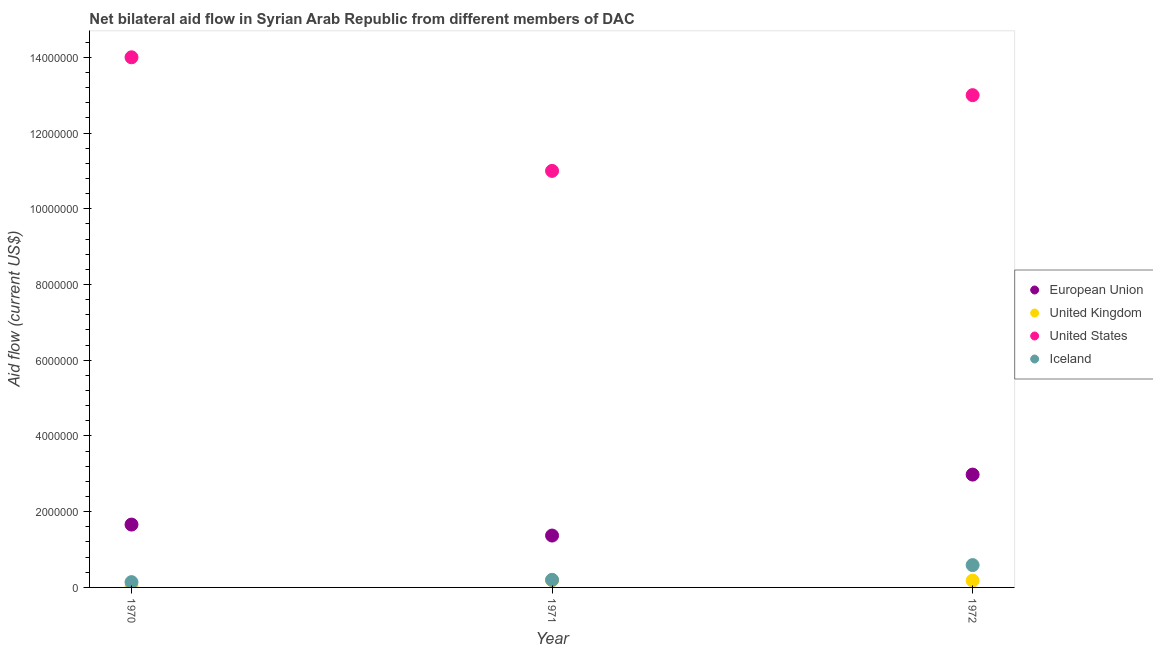How many different coloured dotlines are there?
Your response must be concise. 4. Is the number of dotlines equal to the number of legend labels?
Offer a very short reply. Yes. What is the amount of aid given by eu in 1971?
Ensure brevity in your answer.  1.37e+06. Across all years, what is the maximum amount of aid given by iceland?
Ensure brevity in your answer.  5.90e+05. Across all years, what is the minimum amount of aid given by us?
Provide a succinct answer. 1.10e+07. In which year was the amount of aid given by eu maximum?
Provide a short and direct response. 1972. What is the total amount of aid given by us in the graph?
Offer a terse response. 3.80e+07. What is the difference between the amount of aid given by iceland in 1971 and that in 1972?
Offer a terse response. -3.90e+05. What is the difference between the amount of aid given by uk in 1970 and the amount of aid given by iceland in 1971?
Your answer should be very brief. -1.80e+05. What is the average amount of aid given by eu per year?
Your answer should be very brief. 2.00e+06. In the year 1971, what is the difference between the amount of aid given by uk and amount of aid given by eu?
Keep it short and to the point. -1.18e+06. What is the ratio of the amount of aid given by us in 1971 to that in 1972?
Keep it short and to the point. 0.85. What is the difference between the highest and the lowest amount of aid given by uk?
Offer a very short reply. 1.70e+05. In how many years, is the amount of aid given by iceland greater than the average amount of aid given by iceland taken over all years?
Keep it short and to the point. 1. Is it the case that in every year, the sum of the amount of aid given by iceland and amount of aid given by eu is greater than the sum of amount of aid given by us and amount of aid given by uk?
Offer a terse response. No. Does the amount of aid given by us monotonically increase over the years?
Provide a short and direct response. No. Is the amount of aid given by uk strictly less than the amount of aid given by us over the years?
Your response must be concise. Yes. How many dotlines are there?
Your answer should be compact. 4. How many years are there in the graph?
Ensure brevity in your answer.  3. Does the graph contain any zero values?
Make the answer very short. No. How many legend labels are there?
Ensure brevity in your answer.  4. What is the title of the graph?
Ensure brevity in your answer.  Net bilateral aid flow in Syrian Arab Republic from different members of DAC. Does "Secondary general" appear as one of the legend labels in the graph?
Ensure brevity in your answer.  No. What is the label or title of the X-axis?
Your answer should be compact. Year. What is the label or title of the Y-axis?
Provide a short and direct response. Aid flow (current US$). What is the Aid flow (current US$) in European Union in 1970?
Provide a succinct answer. 1.66e+06. What is the Aid flow (current US$) of United States in 1970?
Provide a succinct answer. 1.40e+07. What is the Aid flow (current US$) of European Union in 1971?
Keep it short and to the point. 1.37e+06. What is the Aid flow (current US$) in United States in 1971?
Offer a terse response. 1.10e+07. What is the Aid flow (current US$) of European Union in 1972?
Offer a terse response. 2.98e+06. What is the Aid flow (current US$) of United States in 1972?
Ensure brevity in your answer.  1.30e+07. What is the Aid flow (current US$) in Iceland in 1972?
Provide a succinct answer. 5.90e+05. Across all years, what is the maximum Aid flow (current US$) of European Union?
Your response must be concise. 2.98e+06. Across all years, what is the maximum Aid flow (current US$) of United Kingdom?
Offer a terse response. 1.90e+05. Across all years, what is the maximum Aid flow (current US$) in United States?
Offer a very short reply. 1.40e+07. Across all years, what is the maximum Aid flow (current US$) in Iceland?
Offer a very short reply. 5.90e+05. Across all years, what is the minimum Aid flow (current US$) in European Union?
Offer a very short reply. 1.37e+06. Across all years, what is the minimum Aid flow (current US$) in United States?
Provide a short and direct response. 1.10e+07. Across all years, what is the minimum Aid flow (current US$) in Iceland?
Ensure brevity in your answer.  1.40e+05. What is the total Aid flow (current US$) in European Union in the graph?
Your response must be concise. 6.01e+06. What is the total Aid flow (current US$) in United Kingdom in the graph?
Make the answer very short. 3.90e+05. What is the total Aid flow (current US$) in United States in the graph?
Offer a very short reply. 3.80e+07. What is the total Aid flow (current US$) in Iceland in the graph?
Provide a succinct answer. 9.30e+05. What is the difference between the Aid flow (current US$) of United Kingdom in 1970 and that in 1971?
Your answer should be very brief. -1.70e+05. What is the difference between the Aid flow (current US$) in United States in 1970 and that in 1971?
Provide a short and direct response. 3.00e+06. What is the difference between the Aid flow (current US$) of Iceland in 1970 and that in 1971?
Make the answer very short. -6.00e+04. What is the difference between the Aid flow (current US$) in European Union in 1970 and that in 1972?
Offer a terse response. -1.32e+06. What is the difference between the Aid flow (current US$) of United States in 1970 and that in 1972?
Keep it short and to the point. 1.00e+06. What is the difference between the Aid flow (current US$) in Iceland in 1970 and that in 1972?
Your response must be concise. -4.50e+05. What is the difference between the Aid flow (current US$) in European Union in 1971 and that in 1972?
Offer a terse response. -1.61e+06. What is the difference between the Aid flow (current US$) of United Kingdom in 1971 and that in 1972?
Offer a very short reply. 10000. What is the difference between the Aid flow (current US$) in Iceland in 1971 and that in 1972?
Give a very brief answer. -3.90e+05. What is the difference between the Aid flow (current US$) of European Union in 1970 and the Aid flow (current US$) of United Kingdom in 1971?
Your response must be concise. 1.47e+06. What is the difference between the Aid flow (current US$) in European Union in 1970 and the Aid flow (current US$) in United States in 1971?
Your answer should be very brief. -9.34e+06. What is the difference between the Aid flow (current US$) of European Union in 1970 and the Aid flow (current US$) of Iceland in 1971?
Make the answer very short. 1.46e+06. What is the difference between the Aid flow (current US$) of United Kingdom in 1970 and the Aid flow (current US$) of United States in 1971?
Keep it short and to the point. -1.10e+07. What is the difference between the Aid flow (current US$) of United States in 1970 and the Aid flow (current US$) of Iceland in 1971?
Your answer should be very brief. 1.38e+07. What is the difference between the Aid flow (current US$) of European Union in 1970 and the Aid flow (current US$) of United Kingdom in 1972?
Give a very brief answer. 1.48e+06. What is the difference between the Aid flow (current US$) of European Union in 1970 and the Aid flow (current US$) of United States in 1972?
Provide a short and direct response. -1.13e+07. What is the difference between the Aid flow (current US$) of European Union in 1970 and the Aid flow (current US$) of Iceland in 1972?
Keep it short and to the point. 1.07e+06. What is the difference between the Aid flow (current US$) of United Kingdom in 1970 and the Aid flow (current US$) of United States in 1972?
Make the answer very short. -1.30e+07. What is the difference between the Aid flow (current US$) in United Kingdom in 1970 and the Aid flow (current US$) in Iceland in 1972?
Make the answer very short. -5.70e+05. What is the difference between the Aid flow (current US$) in United States in 1970 and the Aid flow (current US$) in Iceland in 1972?
Offer a terse response. 1.34e+07. What is the difference between the Aid flow (current US$) of European Union in 1971 and the Aid flow (current US$) of United Kingdom in 1972?
Offer a very short reply. 1.19e+06. What is the difference between the Aid flow (current US$) in European Union in 1971 and the Aid flow (current US$) in United States in 1972?
Your answer should be very brief. -1.16e+07. What is the difference between the Aid flow (current US$) of European Union in 1971 and the Aid flow (current US$) of Iceland in 1972?
Keep it short and to the point. 7.80e+05. What is the difference between the Aid flow (current US$) in United Kingdom in 1971 and the Aid flow (current US$) in United States in 1972?
Give a very brief answer. -1.28e+07. What is the difference between the Aid flow (current US$) of United Kingdom in 1971 and the Aid flow (current US$) of Iceland in 1972?
Ensure brevity in your answer.  -4.00e+05. What is the difference between the Aid flow (current US$) in United States in 1971 and the Aid flow (current US$) in Iceland in 1972?
Your response must be concise. 1.04e+07. What is the average Aid flow (current US$) of European Union per year?
Your answer should be very brief. 2.00e+06. What is the average Aid flow (current US$) in United Kingdom per year?
Offer a very short reply. 1.30e+05. What is the average Aid flow (current US$) of United States per year?
Offer a very short reply. 1.27e+07. What is the average Aid flow (current US$) in Iceland per year?
Provide a succinct answer. 3.10e+05. In the year 1970, what is the difference between the Aid flow (current US$) in European Union and Aid flow (current US$) in United Kingdom?
Provide a succinct answer. 1.64e+06. In the year 1970, what is the difference between the Aid flow (current US$) of European Union and Aid flow (current US$) of United States?
Your response must be concise. -1.23e+07. In the year 1970, what is the difference between the Aid flow (current US$) of European Union and Aid flow (current US$) of Iceland?
Your answer should be very brief. 1.52e+06. In the year 1970, what is the difference between the Aid flow (current US$) in United Kingdom and Aid flow (current US$) in United States?
Offer a terse response. -1.40e+07. In the year 1970, what is the difference between the Aid flow (current US$) in United Kingdom and Aid flow (current US$) in Iceland?
Offer a very short reply. -1.20e+05. In the year 1970, what is the difference between the Aid flow (current US$) in United States and Aid flow (current US$) in Iceland?
Offer a very short reply. 1.39e+07. In the year 1971, what is the difference between the Aid flow (current US$) of European Union and Aid flow (current US$) of United Kingdom?
Provide a short and direct response. 1.18e+06. In the year 1971, what is the difference between the Aid flow (current US$) in European Union and Aid flow (current US$) in United States?
Offer a terse response. -9.63e+06. In the year 1971, what is the difference between the Aid flow (current US$) in European Union and Aid flow (current US$) in Iceland?
Ensure brevity in your answer.  1.17e+06. In the year 1971, what is the difference between the Aid flow (current US$) in United Kingdom and Aid flow (current US$) in United States?
Make the answer very short. -1.08e+07. In the year 1971, what is the difference between the Aid flow (current US$) in United Kingdom and Aid flow (current US$) in Iceland?
Ensure brevity in your answer.  -10000. In the year 1971, what is the difference between the Aid flow (current US$) of United States and Aid flow (current US$) of Iceland?
Ensure brevity in your answer.  1.08e+07. In the year 1972, what is the difference between the Aid flow (current US$) in European Union and Aid flow (current US$) in United Kingdom?
Provide a short and direct response. 2.80e+06. In the year 1972, what is the difference between the Aid flow (current US$) of European Union and Aid flow (current US$) of United States?
Give a very brief answer. -1.00e+07. In the year 1972, what is the difference between the Aid flow (current US$) in European Union and Aid flow (current US$) in Iceland?
Ensure brevity in your answer.  2.39e+06. In the year 1972, what is the difference between the Aid flow (current US$) of United Kingdom and Aid flow (current US$) of United States?
Offer a terse response. -1.28e+07. In the year 1972, what is the difference between the Aid flow (current US$) of United Kingdom and Aid flow (current US$) of Iceland?
Give a very brief answer. -4.10e+05. In the year 1972, what is the difference between the Aid flow (current US$) in United States and Aid flow (current US$) in Iceland?
Your response must be concise. 1.24e+07. What is the ratio of the Aid flow (current US$) of European Union in 1970 to that in 1971?
Provide a succinct answer. 1.21. What is the ratio of the Aid flow (current US$) in United Kingdom in 1970 to that in 1971?
Your answer should be very brief. 0.11. What is the ratio of the Aid flow (current US$) in United States in 1970 to that in 1971?
Offer a very short reply. 1.27. What is the ratio of the Aid flow (current US$) in European Union in 1970 to that in 1972?
Offer a very short reply. 0.56. What is the ratio of the Aid flow (current US$) in Iceland in 1970 to that in 1972?
Make the answer very short. 0.24. What is the ratio of the Aid flow (current US$) in European Union in 1971 to that in 1972?
Make the answer very short. 0.46. What is the ratio of the Aid flow (current US$) in United Kingdom in 1971 to that in 1972?
Provide a succinct answer. 1.06. What is the ratio of the Aid flow (current US$) of United States in 1971 to that in 1972?
Provide a succinct answer. 0.85. What is the ratio of the Aid flow (current US$) in Iceland in 1971 to that in 1972?
Provide a succinct answer. 0.34. What is the difference between the highest and the second highest Aid flow (current US$) in European Union?
Your response must be concise. 1.32e+06. What is the difference between the highest and the lowest Aid flow (current US$) of European Union?
Your response must be concise. 1.61e+06. What is the difference between the highest and the lowest Aid flow (current US$) in United Kingdom?
Your answer should be very brief. 1.70e+05. 